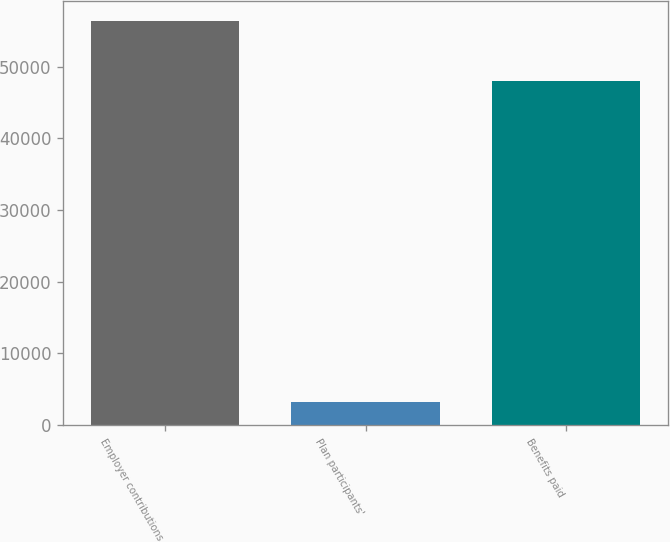Convert chart to OTSL. <chart><loc_0><loc_0><loc_500><loc_500><bar_chart><fcel>Employer contributions<fcel>Plan participants'<fcel>Benefits paid<nl><fcel>56328<fcel>3219<fcel>48027<nl></chart> 